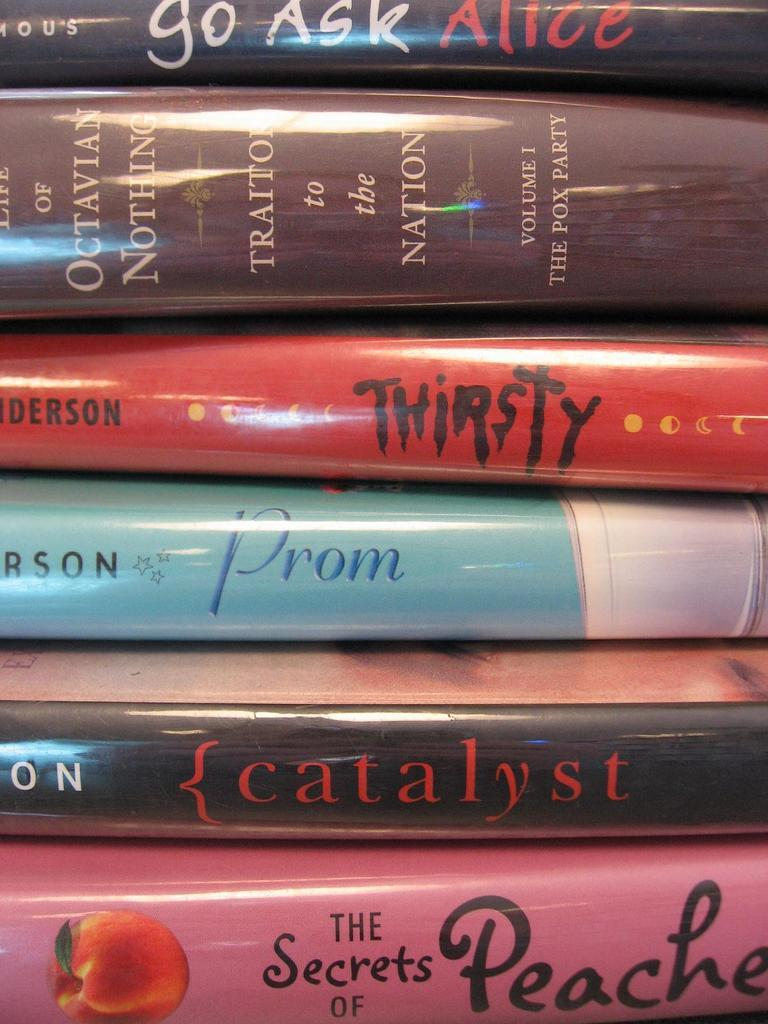<image>
Provide a brief description of the given image. A stack of books one is titled prom. 